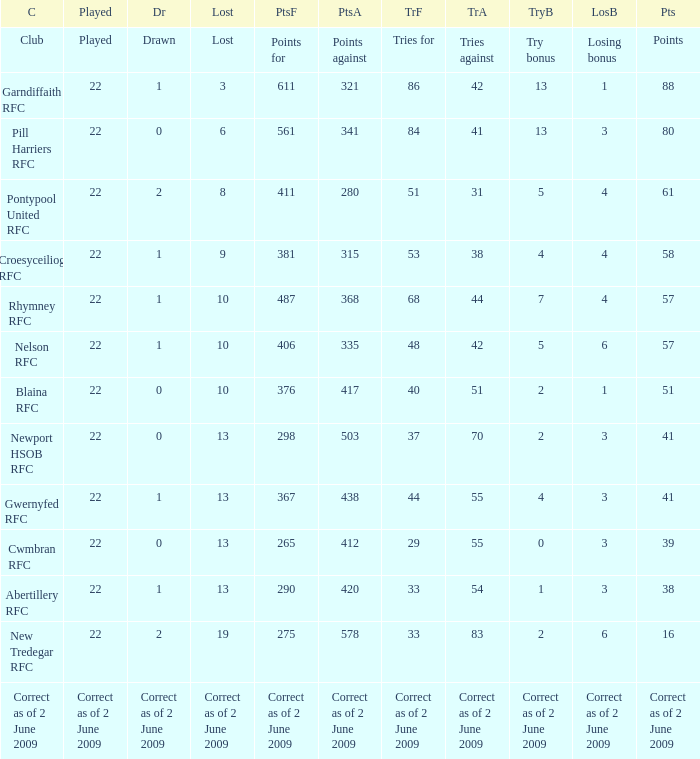How many tries did the club with a try bonus of correct as of 2 June 2009 have? Correct as of 2 June 2009. 